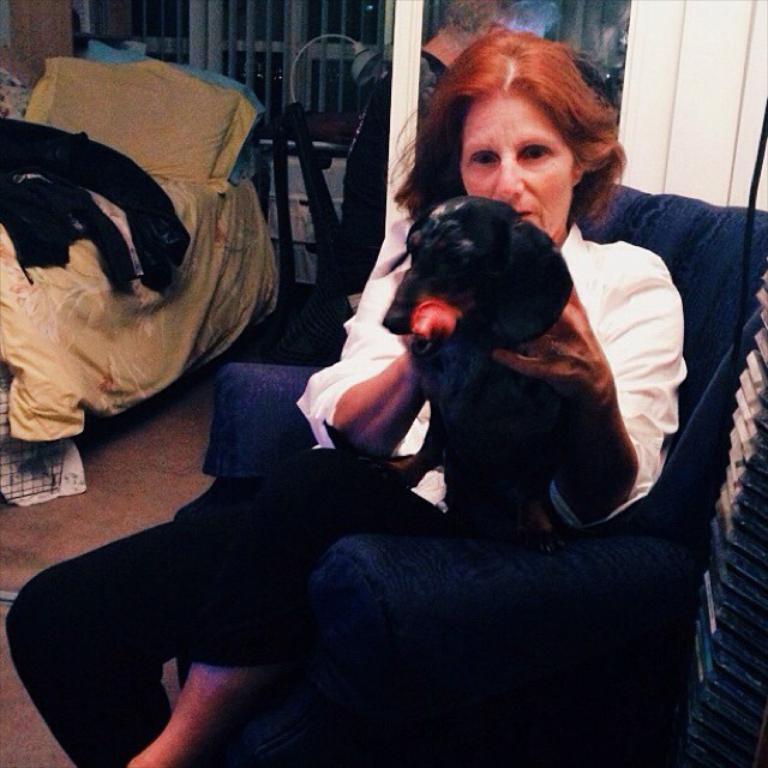Who is present in the image? There is a woman in the image. What is the woman doing in the image? The woman is sitting on a chair. Are there any animals in the image? Yes, there is a dog in the image. What type of furniture is visible in the image? There is a bed and a chair in the image. What is on the bed in the image? There is a pillow on the bed. What is the surface beneath the furniture in the image? There is a floor in the image. What type of credit card does the woman use to pay for lunch in the image? There is no credit card or lunch depicted in the image. 